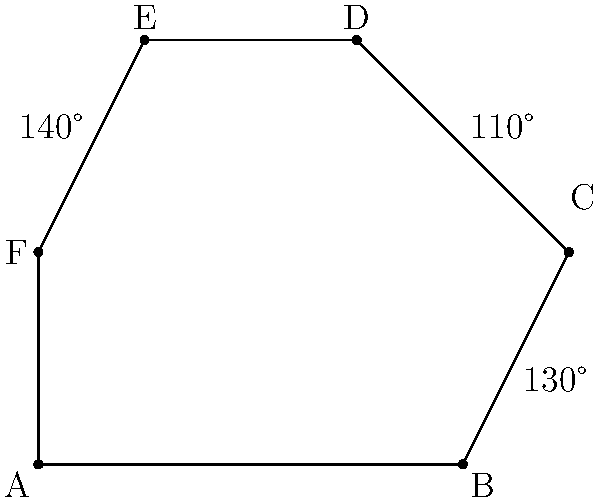A luxury perfume bottle endorsed by a celebrity has an irregular hexagonal shape. Three of its interior angles are known: $\angle ABC = 130°$, $\angle BCD = 110°$, and $\angle EFA = 140°$. What is the measure of $\angle DEF$? Let's approach this step-by-step:

1) First, recall that the sum of interior angles of a hexagon is $(n-2) \times 180°$, where $n$ is the number of sides. For a hexagon, this is:

   $(6-2) \times 180° = 4 \times 180° = 720°$

2) We know three of the angles:
   $\angle ABC = 130°$
   $\angle BCD = 110°$
   $\angle EFA = 140°$

3) Let's call the unknown angles:
   $\angle CDE = x$
   $\angle DEF = y$ (this is what we're looking for)
   $\angle FED = z$

4) We can set up an equation based on the fact that all angles must sum to 720°:

   $130° + 110° + x + y + z + 140° = 720°$

5) Simplify:
   $380° + x + y + z = 720°$

6) We also know that $x + y + z = 360°$ (because these three angles form a straight line on one side of the hexagon)

7) Substitute this into our equation:
   $380° + 360° = 720°$

8) This confirms that our logic is correct. Now, to find $y$ ($\angle DEF$), we can use the fact that $x + y + z = 360°$

9) We don't know $x$ or $z$ individually, but we know their sum:
   $x + z = 360° - y$

10) The sum of all angles in the hexagon minus the known angles and $y$ will give us $x + z$:
    $720° - (130° + 110° + 140° + y) = x + z = 360° - y$

11) Solve this equation:
    $340° - y = 360° - y$
    $340° = 360°$
    $y = 20°$

Therefore, $\angle DEF = 20°$.
Answer: $20°$ 